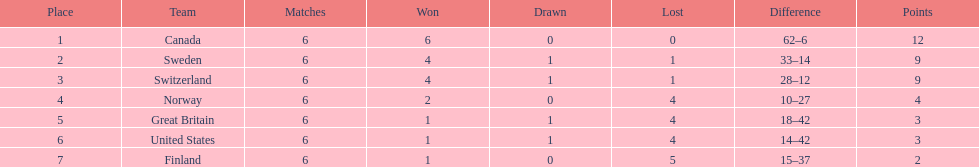Which country had a lower position than the united states? Finland. 